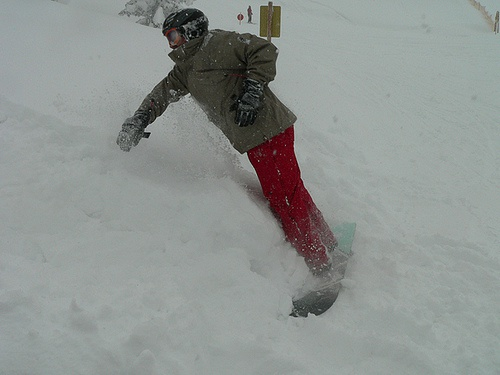Describe the objects in this image and their specific colors. I can see people in darkgray, black, maroon, and gray tones, snowboard in darkgray, gray, and black tones, and people in darkgray, gray, maroon, and black tones in this image. 